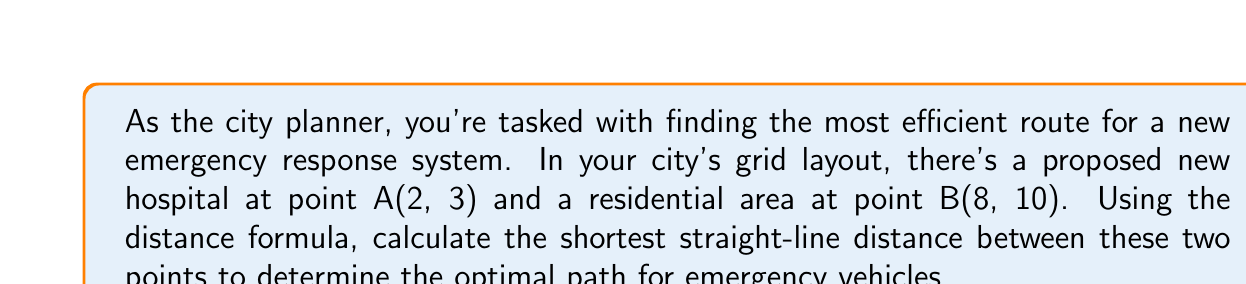Can you solve this math problem? To solve this problem, we'll use the distance formula derived from the Pythagorean theorem. The distance formula for two points $(x_1, y_1)$ and $(x_2, y_2)$ is:

$$ d = \sqrt{(x_2 - x_1)^2 + (y_2 - y_1)^2} $$

Let's plug in our values:
- Point A (hospital): $(x_1, y_1) = (2, 3)$
- Point B (residential area): $(x_2, y_2) = (8, 10)$

Now, let's substitute these into our formula:

$$ d = \sqrt{(8 - 2)^2 + (10 - 3)^2} $$

Simplify inside the parentheses:

$$ d = \sqrt{6^2 + 7^2} $$

Calculate the squares:

$$ d = \sqrt{36 + 49} $$

Add under the square root:

$$ d = \sqrt{85} $$

This is our final answer, but we can simplify it further for a decimal approximation:

$$ d \approx 9.22 $$

[asy]
unitsize(0.5cm);
draw((-1,-1)--(10,12),gray);
draw((0,0)--(10,0),gray);
draw((0,0)--(0,12),gray);
dot((2,3));
dot((8,10));
draw((2,3)--(8,10),red);
label("A (2,3)", (2,3), SW);
label("B (8,10)", (8,10), NE);
label("d", (5,6.5), NW);
[/asy]

The red line in the diagram represents the shortest path between points A and B.
Answer: The shortest straight-line distance between the hospital at A(2, 3) and the residential area at B(8, 10) is $\sqrt{85}$ units, or approximately 9.22 units. 